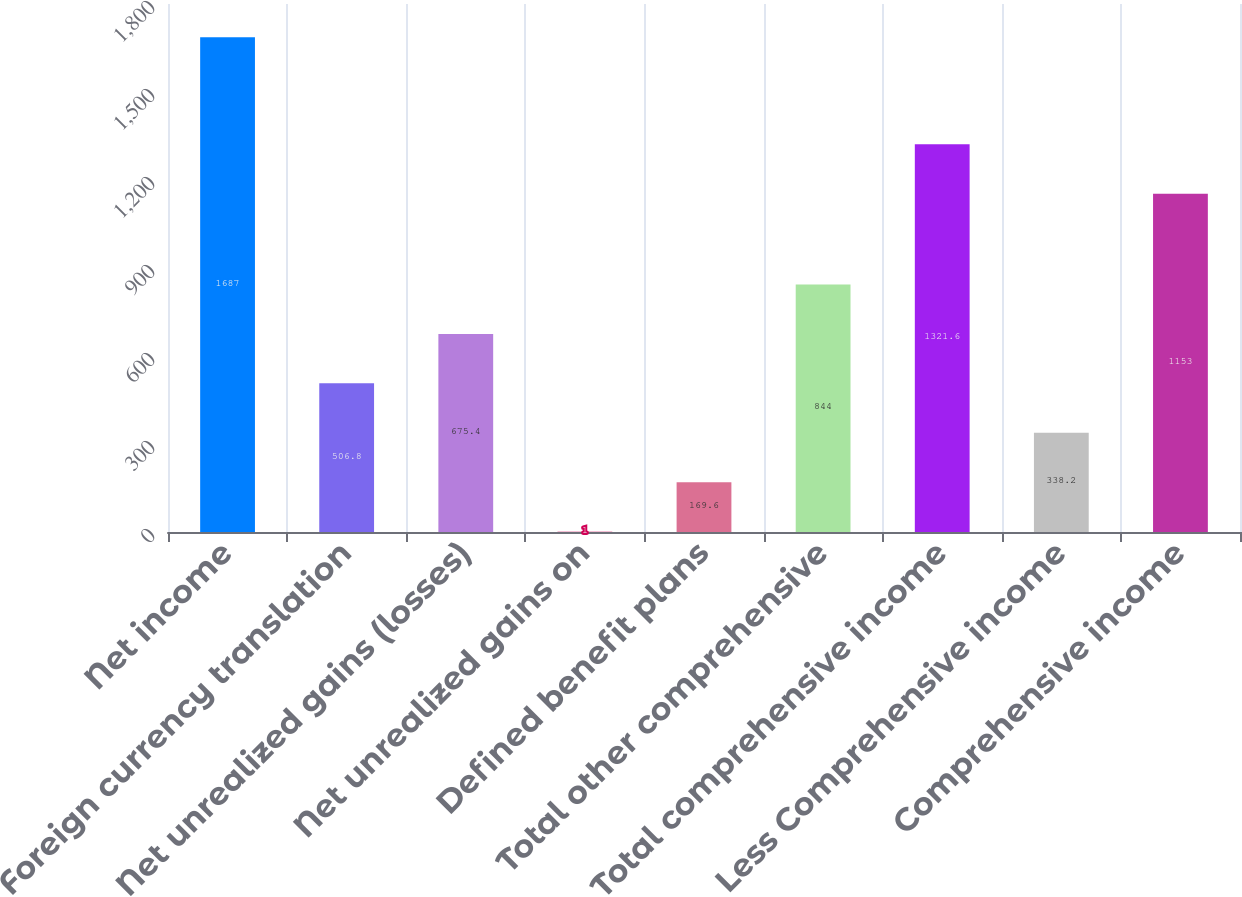Convert chart. <chart><loc_0><loc_0><loc_500><loc_500><bar_chart><fcel>Net income<fcel>Foreign currency translation<fcel>Net unrealized gains (losses)<fcel>Net unrealized gains on<fcel>Defined benefit plans<fcel>Total other comprehensive<fcel>Total comprehensive income<fcel>Less Comprehensive income<fcel>Comprehensive income<nl><fcel>1687<fcel>506.8<fcel>675.4<fcel>1<fcel>169.6<fcel>844<fcel>1321.6<fcel>338.2<fcel>1153<nl></chart> 